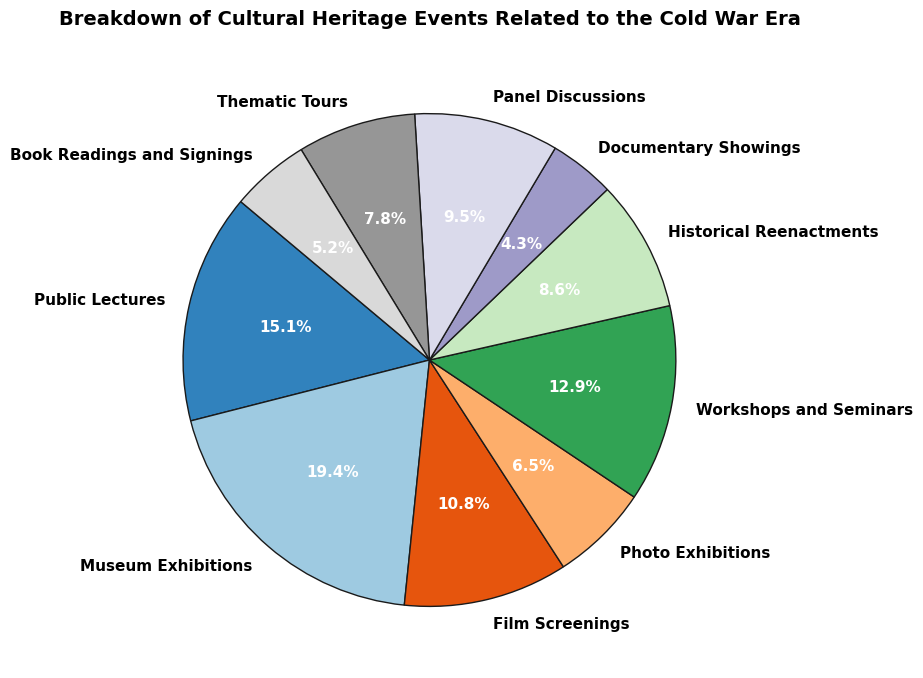1. Which event type has the highest number of events? The segment representing Museum Exhibitions appears the largest.
Answer: Museum Exhibitions 2. What is the percentage share of Film Screenings out of the total events? Locate the segment for Film Screenings; the percentage displayed is 12.5%.
Answer: 12.5% 3. Which two event types together have the smallest share of events? Documentary Showings and Book Readings and Signings have the smallest individual percentages. Adding them confirms they are the smallest combined share.
Answer: Documentary Showings and Book Readings and Signings 4. How many more Public Lectures are there than Documentary Showings? Subtract the number of Documentary Showings (10) from the number of Public Lectures (35). The difference is 35 - 10 = 25.
Answer: 25 5. What is the combined percentage share of Workshops and Seminars and Public Lectures? Add the percentages for Workshops and Seminars (17.1%) and Public Lectures (20.0%). The total is 17.1% + 20.0% = 37.1%.
Answer: 37.1% 6. What fraction of the total events are Historical Reenactments? The percentage for Historical Reenactments is 11.4%, which translates to the fraction 11.4/100 = 0.114. Simplify if possible.
Answer: 11.4% 7. Do Panel Discussions account for more events than Thematic Tours? Compare the percentages: Panel Discussions (12.6%) and Thematic Tours (10.3%). Panel Discussions have a higher percentage.
Answer: Yes 8. Which events have a percentage share between 10% and 15%? Check the segment labels and percentages, identifying Panel Discussions (12.6%), Historical Reenactments (11.4%), and Thematic Tours (10.3%).
Answer: Panel Discussions, Historical Reenactments, Thematic Tours 9. What is the total number of events accounted for by Public Lectures and Museum Exhibitions? Add the number of Public Lectures (35) and Museum Exhibitions (45). The total is 35 + 45 = 80.
Answer: 80 10. How does the number of Photo Exhibitions compare to that of Film Screenings? The number of Photo Exhibitions (15) is less than the number of Film Screenings (25).
Answer: Less 